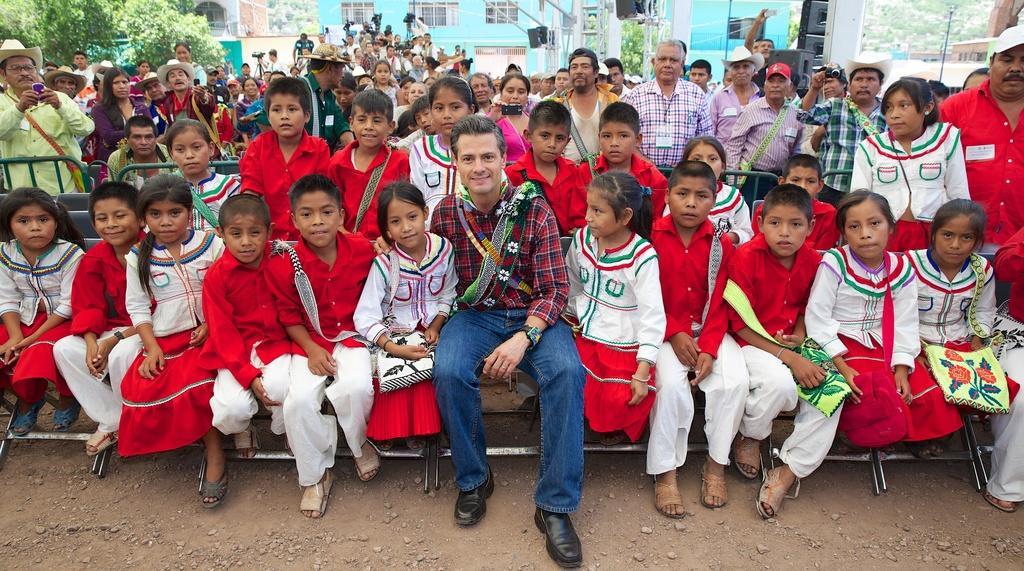Please provide a concise description of this image. In this picture there is a man who is the wearing shirt, match, jeans and shoe. He is sitting on the bench, besides him i can see many children. In the back I can see some peoples were standing behind the fencing and some peoples are holding camera and mobile phone. In the background I can see the cameraman who are holding the camera and they are standing near to the building and poles. On the top left corner i can see the trees. In the top right corner there is a pole near to the road. 